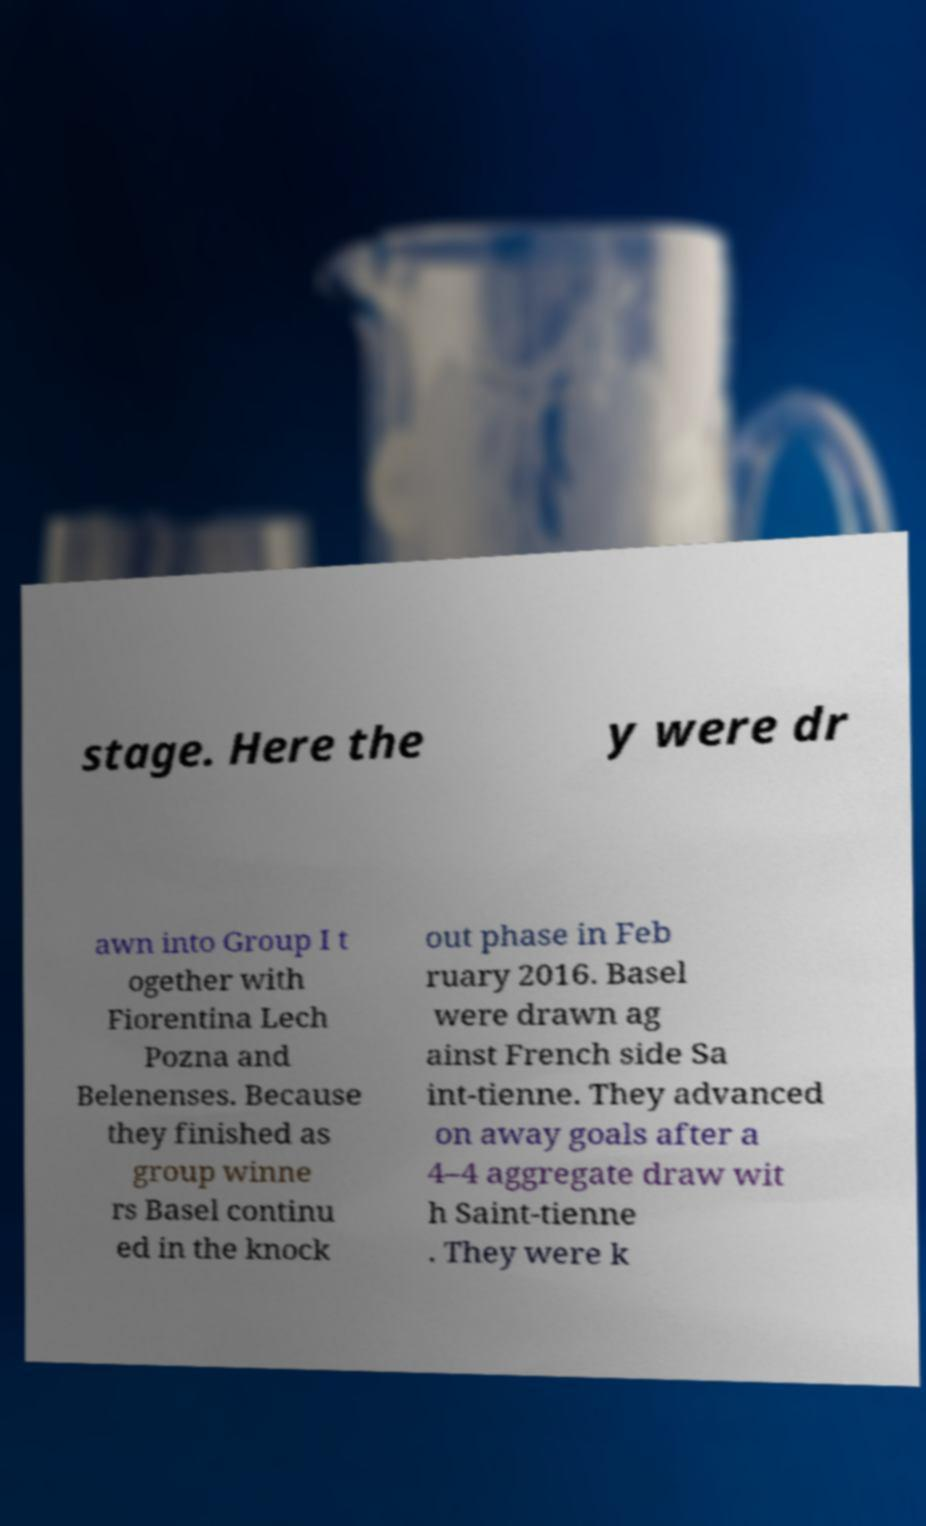Could you extract and type out the text from this image? stage. Here the y were dr awn into Group I t ogether with Fiorentina Lech Pozna and Belenenses. Because they finished as group winne rs Basel continu ed in the knock out phase in Feb ruary 2016. Basel were drawn ag ainst French side Sa int-tienne. They advanced on away goals after a 4–4 aggregate draw wit h Saint-tienne . They were k 